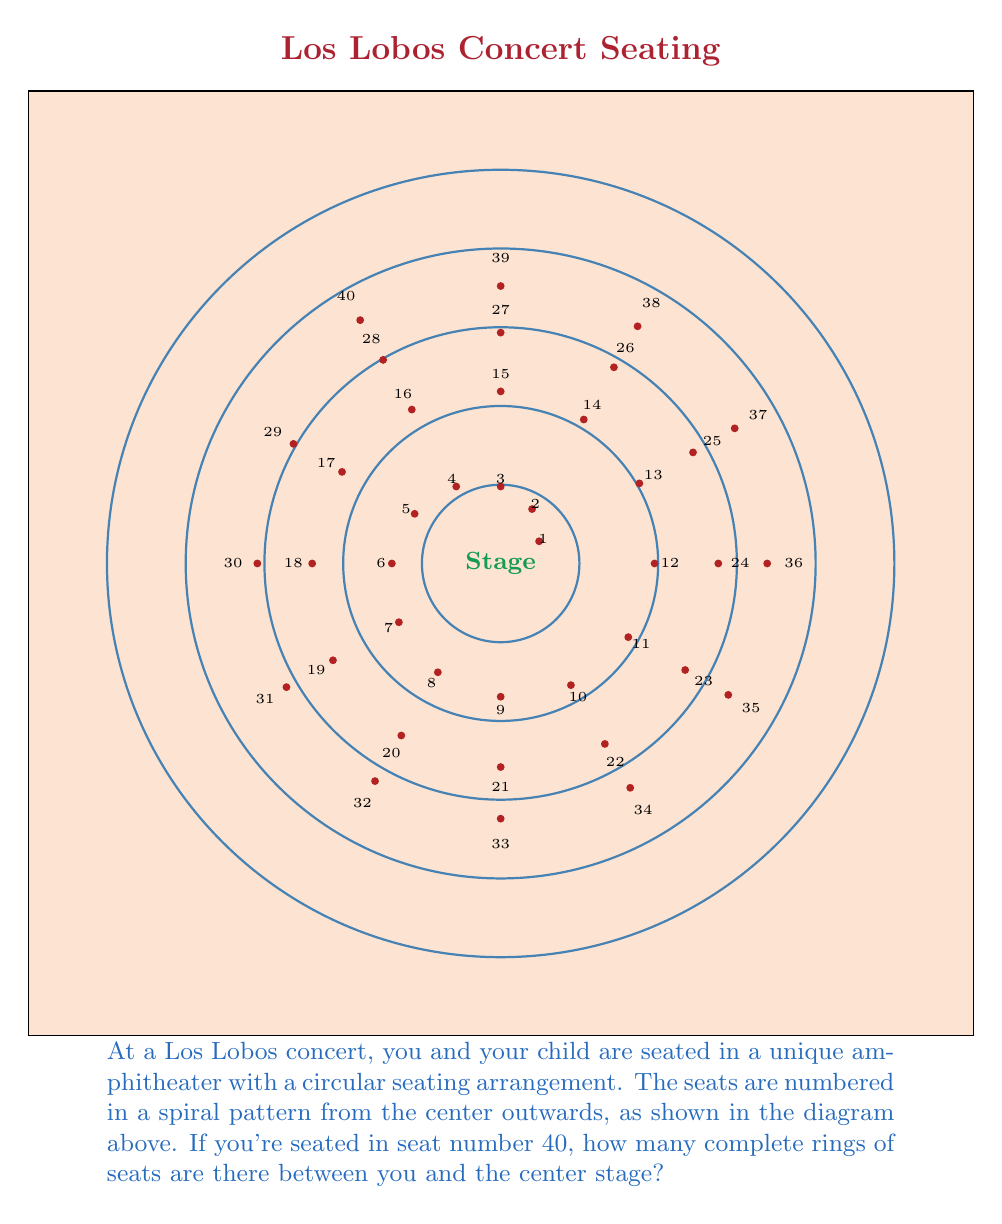Show me your answer to this math problem. To solve this problem, we need to understand the pattern of seat numbers in each ring:

1. The first (innermost) ring has 6 seats (1-6)
2. The second ring has 12 seats (7-18)
3. The third ring has 18 seats (19-36)
4. The fourth ring has 24 seats (37-60)

We can observe that each ring adds 6 more seats than the previous one. To find which ring seat 40 is in, we need to:

1. Calculate the cumulative sum of seats up to each ring
2. Find the first cumulative sum that exceeds 40

Let's calculate:

1. First ring: $6$ seats (cumulative: $6$)
2. Second ring: $6 + 12 = 18$ seats (cumulative: $6 + 18 = 24$)
3. Third ring: $6 + 12 + 18 = 36$ seats (cumulative: $6 + 18 + 36 = 60$)

We see that the third ring's cumulative sum (60) exceeds 40, so seat 40 is in the third ring.

To find how many complete rings are between seat 40 and the center stage, we simply subtract 1 from the ring number:

$3 - 1 = 2$ complete rings
Answer: 2 